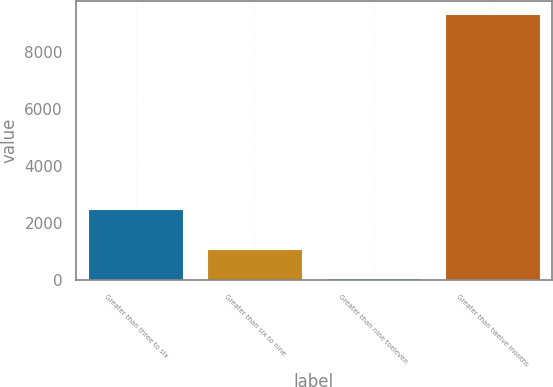<chart> <loc_0><loc_0><loc_500><loc_500><bar_chart><fcel>Greater than three to six<fcel>Greater than six to nine<fcel>Greater than nine toeleven<fcel>Greater than twelve months<nl><fcel>2517<fcel>1097<fcel>95<fcel>9324<nl></chart> 